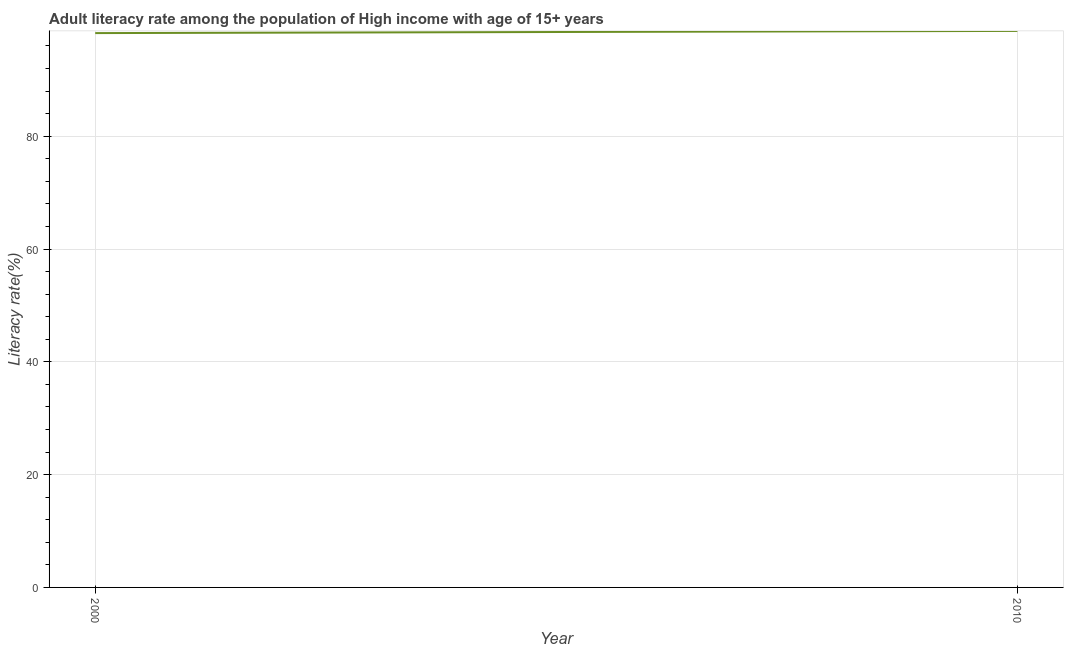What is the adult literacy rate in 2000?
Provide a short and direct response. 98.29. Across all years, what is the maximum adult literacy rate?
Ensure brevity in your answer.  98.67. Across all years, what is the minimum adult literacy rate?
Ensure brevity in your answer.  98.29. What is the sum of the adult literacy rate?
Make the answer very short. 196.96. What is the difference between the adult literacy rate in 2000 and 2010?
Ensure brevity in your answer.  -0.38. What is the average adult literacy rate per year?
Your response must be concise. 98.48. What is the median adult literacy rate?
Offer a terse response. 98.48. What is the ratio of the adult literacy rate in 2000 to that in 2010?
Provide a short and direct response. 1. Is the adult literacy rate in 2000 less than that in 2010?
Provide a short and direct response. Yes. Does the adult literacy rate monotonically increase over the years?
Offer a very short reply. Yes. How many lines are there?
Give a very brief answer. 1. How many years are there in the graph?
Offer a terse response. 2. What is the difference between two consecutive major ticks on the Y-axis?
Provide a succinct answer. 20. Are the values on the major ticks of Y-axis written in scientific E-notation?
Offer a very short reply. No. Does the graph contain any zero values?
Make the answer very short. No. Does the graph contain grids?
Your response must be concise. Yes. What is the title of the graph?
Your answer should be compact. Adult literacy rate among the population of High income with age of 15+ years. What is the label or title of the X-axis?
Your answer should be very brief. Year. What is the label or title of the Y-axis?
Keep it short and to the point. Literacy rate(%). What is the Literacy rate(%) in 2000?
Your answer should be compact. 98.29. What is the Literacy rate(%) in 2010?
Give a very brief answer. 98.67. What is the difference between the Literacy rate(%) in 2000 and 2010?
Offer a terse response. -0.38. What is the ratio of the Literacy rate(%) in 2000 to that in 2010?
Offer a very short reply. 1. 